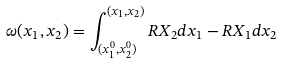<formula> <loc_0><loc_0><loc_500><loc_500>\omega ( x _ { 1 } , x _ { 2 } ) = \int _ { ( x _ { 1 } ^ { 0 } , x _ { 2 } ^ { 0 } ) } ^ { ( x _ { 1 } , x _ { 2 } ) } R X _ { 2 } d x _ { 1 } - R X _ { 1 } d x _ { 2 }</formula> 